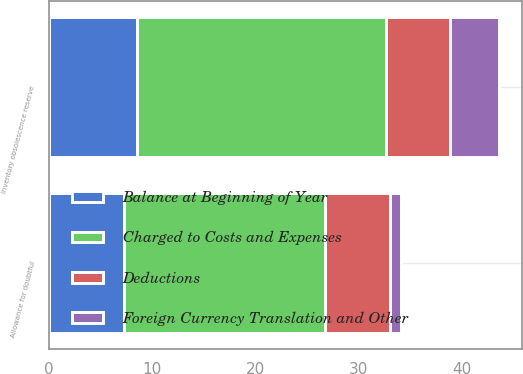Convert chart to OTSL. <chart><loc_0><loc_0><loc_500><loc_500><stacked_bar_chart><ecel><fcel>Allowance for doubtful<fcel>Inventory obsolescence reserve<nl><fcel>Charged to Costs and Expenses<fcel>19.5<fcel>24.1<nl><fcel>Deductions<fcel>6.3<fcel>6.2<nl><fcel>Balance at Beginning of Year<fcel>7.21<fcel>8.52<nl><fcel>Foreign Currency Translation and Other<fcel>1.1<fcel>4.8<nl></chart> 